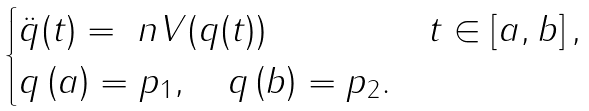Convert formula to latex. <formula><loc_0><loc_0><loc_500><loc_500>\begin{cases} \ddot { q } ( t ) = \ n V ( q ( t ) ) \quad & t \in \left [ a , b \right ] , \\ q \left ( a \right ) = p _ { 1 } , \quad q \left ( b \right ) = p _ { 2 } . \end{cases}</formula> 